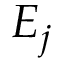Convert formula to latex. <formula><loc_0><loc_0><loc_500><loc_500>E _ { j }</formula> 